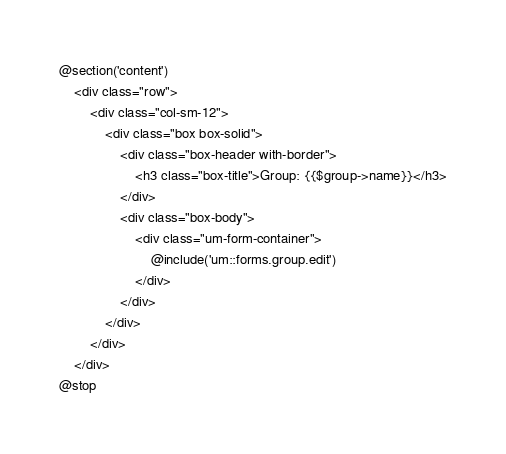Convert code to text. <code><loc_0><loc_0><loc_500><loc_500><_PHP_>@section('content')
    <div class="row">
        <div class="col-sm-12">
            <div class="box box-solid">
                <div class="box-header with-border">
                    <h3 class="box-title">Group: {{$group->name}}</h3>
                </div>
                <div class="box-body">
                    <div class="um-form-container">
                        @include('um::forms.group.edit')
                    </div>
                </div>
            </div>
        </div>
    </div>
@stop
</code> 